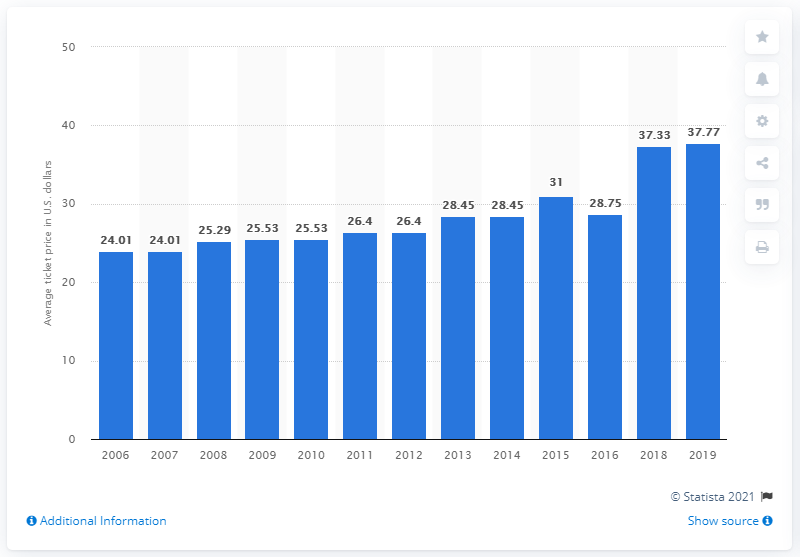Point out several critical features in this image. The average ticket price for Seattle Mariners games in 2019 was $37.77. 